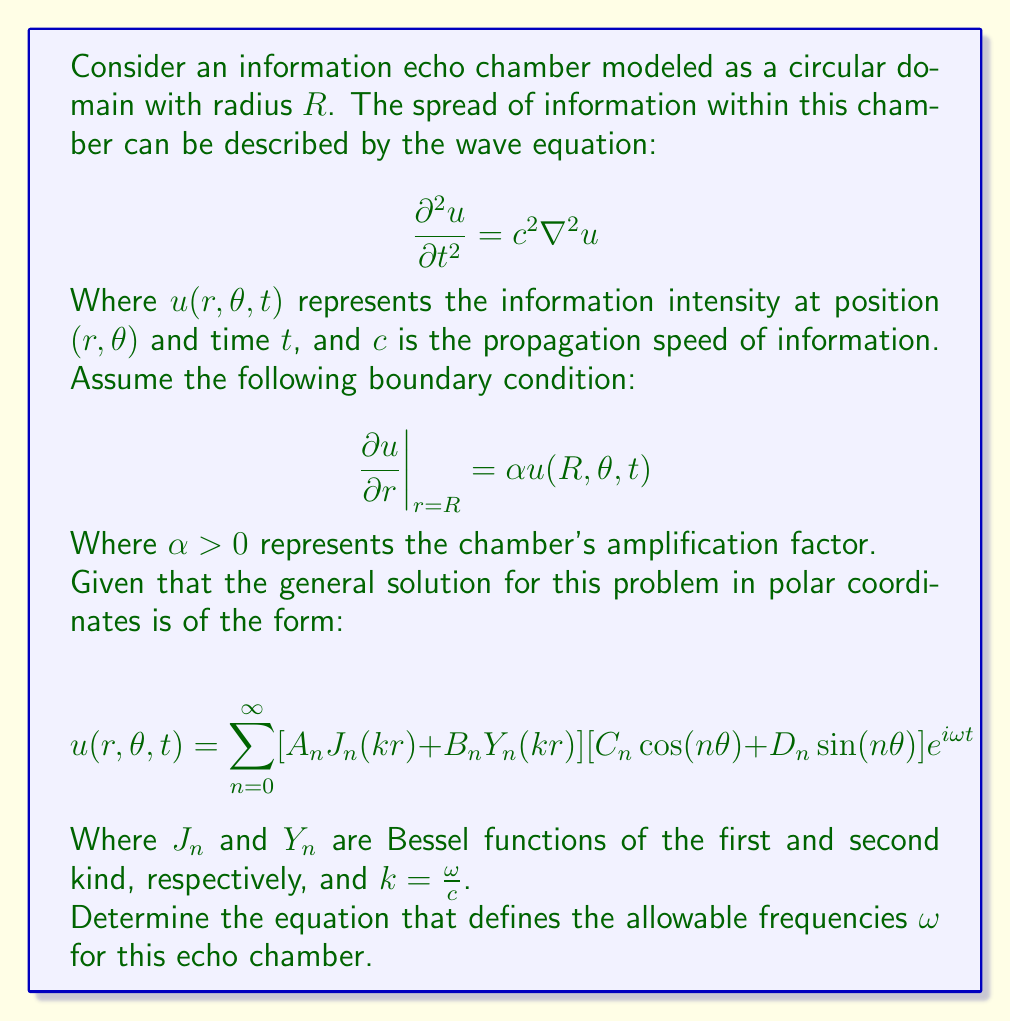Solve this math problem. To solve this problem, we need to apply the boundary condition to the general solution and derive an equation for the allowable frequencies. Let's proceed step-by-step:

1) First, we need to apply the boundary condition at $r=R$:

   $$\frac{\partial u}{\partial r}\bigg|_{r=R} = \alpha u(R,\theta,t)$$

2) Let's focus on the radial part of the solution, as the angular and time parts will be the same on both sides of the equation:

   $$\frac{\partial}{\partial r}[A_n J_n(kr) + B_n Y_n(kr)]\bigg|_{r=R} = \alpha [A_n J_n(kR) + B_n Y_n(kR)]$$

3) Using the properties of Bessel functions, we can write:

   $$A_n k J_n'(kR) + B_n k Y_n'(kR) = \alpha [A_n J_n(kR) + B_n Y_n(kR)]$$

4) For non-trivial solutions $(A_n, B_n \neq 0)$, we require:

   $$\begin{vmatrix}
   k J_n'(kR) - \alpha J_n(kR) & k Y_n'(kR) - \alpha Y_n(kR)
   \end{vmatrix} = 0$$

5) This determinant equation can be simplified to:

   $$k [J_n'(kR) Y_n(kR) - J_n(kR) Y_n'(kR)] = \alpha J_n(kR) Y_n(kR) - \alpha J_n(kR) Y_n(kR) = 0$$

6) The left side of this equation is related to the Wronskian of Bessel functions:

   $$W\{J_n(x), Y_n(x)\} = J_n(x) Y_n'(x) - J_n'(x) Y_n(x) = \frac{2}{\pi x}$$

7) Therefore, our equation becomes:

   $$k \cdot \frac{-2}{\pi kR} = 0$$

8) This is always true for any $k$ (except $k=0$), which means there are no restrictions on $k$ or $\omega$ based on this boundary condition alone.

9) However, the amplification factor $\alpha$ does influence the relative amplitudes of $J_n$ and $Y_n$ in the solution:

   $$\frac{B_n}{A_n} = \frac{k J_n'(kR) - \alpha J_n(kR)}{k Y_n'(kR) - \alpha Y_n(kR)}$$

This ratio determines how much the solution relies on $Y_n$ (which grows unbounded as $r \to 0$) compared to $J_n$, potentially leading to more extreme amplification of information near the center of the echo chamber for larger $\alpha$.
Answer: The equation defining the allowable frequencies $\omega$ for this echo chamber is:

$$k \cdot \frac{2}{\pi kR} = 0$$

This is always satisfied for any non-zero $k = \frac{\omega}{c}$, implying that all frequencies are allowed. However, the amplification factor $\alpha$ influences the relative amplitudes of $J_n$ and $Y_n$ in the solution, potentially leading to more extreme information amplification for larger $\alpha$. 